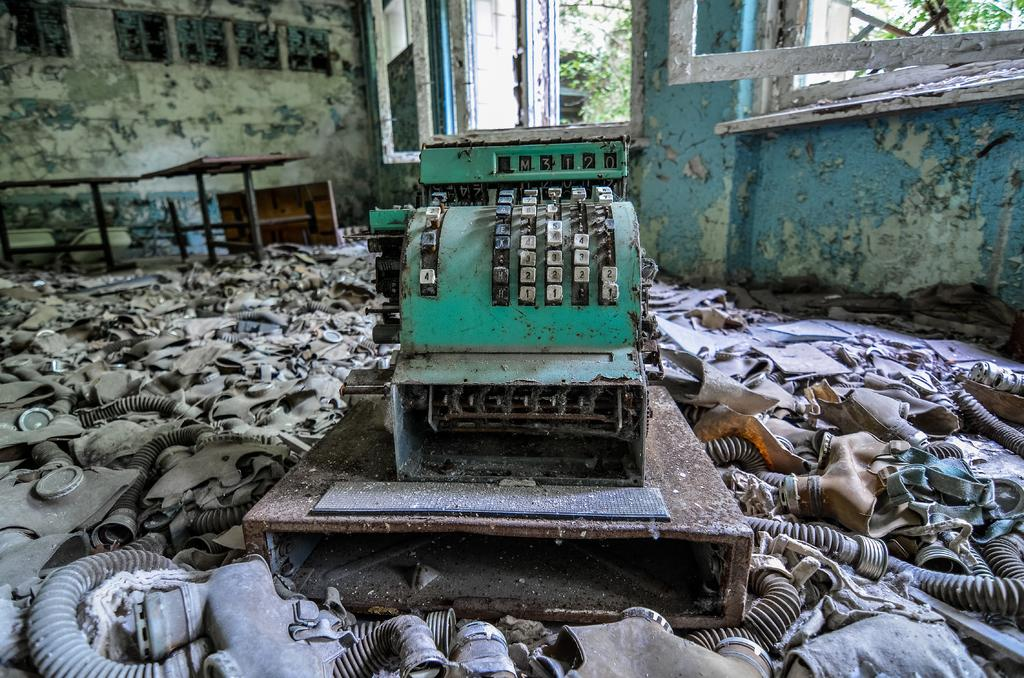What is located in the foreground of the image? There is a machine and pipes in the foreground of the image. What can be seen in the background of the image? There are trees, other items, and the sky visible in the background of the image. Are there any openings in the image that allow for light to enter? Yes, there are windows visible in the image. What type of lace can be seen on the windows in the image? There is no lace visible on the windows in the image. What color is the farm in the image? There is no farm present in the image. 